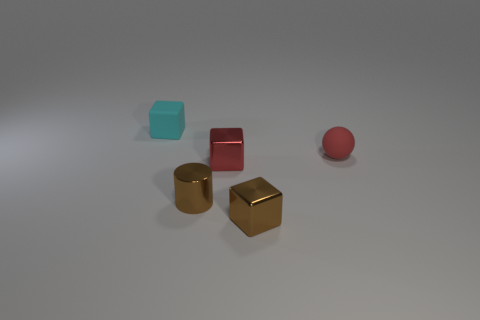Subtract all cyan cubes. Subtract all green cylinders. How many cubes are left? 2 Add 2 red balls. How many objects exist? 7 Subtract all cylinders. How many objects are left? 4 Subtract all metal objects. Subtract all tiny cyan rubber cubes. How many objects are left? 1 Add 3 brown cubes. How many brown cubes are left? 4 Add 4 metal cylinders. How many metal cylinders exist? 5 Subtract 1 cyan blocks. How many objects are left? 4 